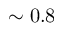Convert formula to latex. <formula><loc_0><loc_0><loc_500><loc_500>\sim 0 . 8</formula> 